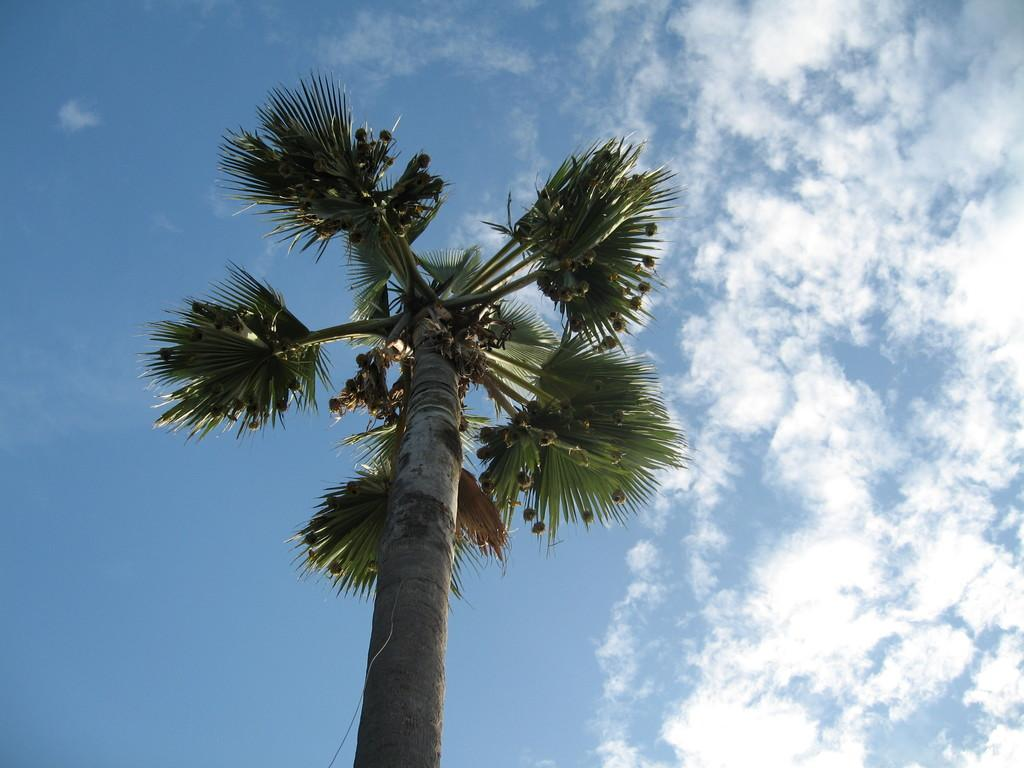What is the main subject of the image? The main subject of the image is a tree. Can you describe the colors of the tree? The tree has green, black, and grey colors. What else can be seen on the tree? There are fruits on the tree. What is visible in the background of the image? The sky is visible in the background of the image. How many stars can be seen in the image? There are no stars visible in the image; it features a tree with fruits and a sky background. Can you describe the group of parents in the image? There is no group of parents present in the image; it only features a tree with fruits and a sky background. 